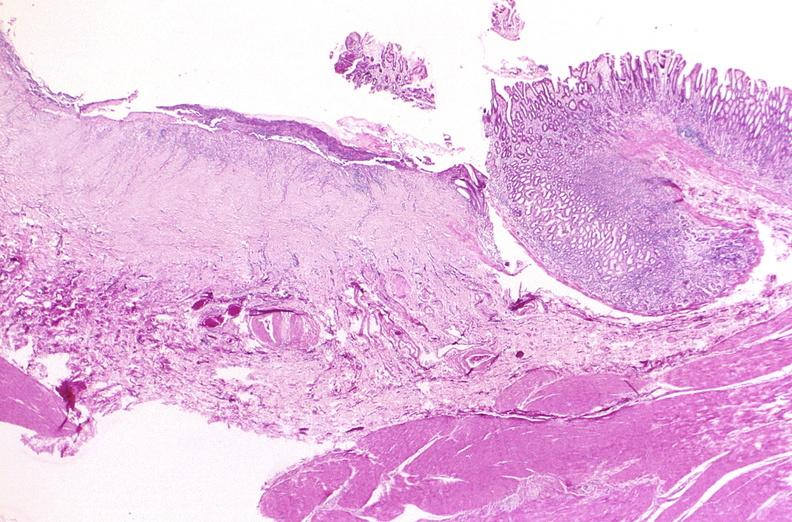where is this from?
Answer the question using a single word or phrase. Gastrointestinal system 